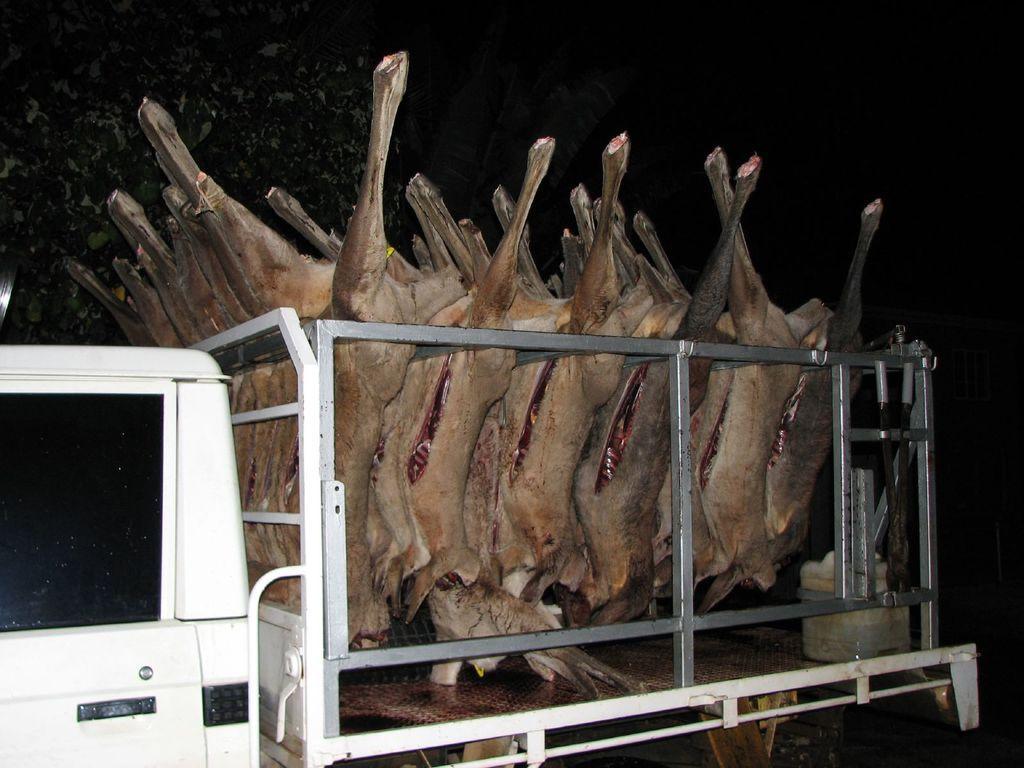Please provide a concise description of this image. In this image in front there is a truck carrying an animal meat. 